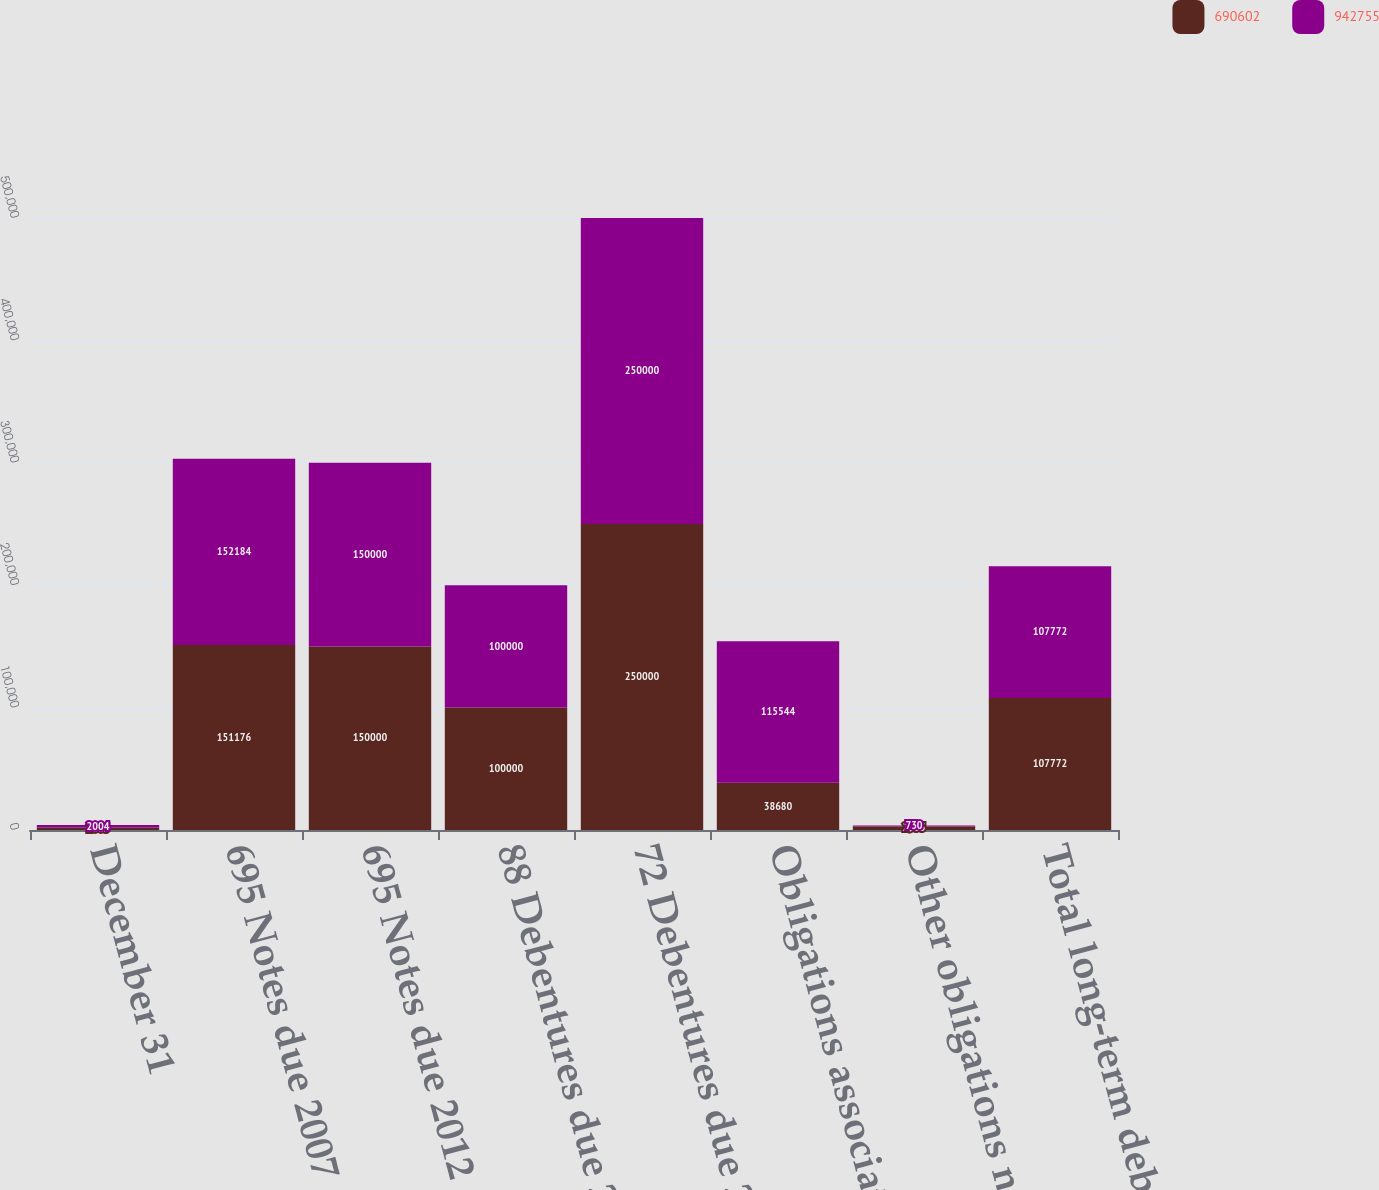Convert chart to OTSL. <chart><loc_0><loc_0><loc_500><loc_500><stacked_bar_chart><ecel><fcel>December 31<fcel>695 Notes due 2007<fcel>695 Notes due 2012<fcel>88 Debentures due 2021<fcel>72 Debentures due 2027<fcel>Obligations associated with<fcel>Other obligations net of<fcel>Total long-term debt<nl><fcel>690602<fcel>2005<fcel>151176<fcel>150000<fcel>100000<fcel>250000<fcel>38680<fcel>2955<fcel>107772<nl><fcel>942755<fcel>2004<fcel>152184<fcel>150000<fcel>100000<fcel>250000<fcel>115544<fcel>730<fcel>107772<nl></chart> 